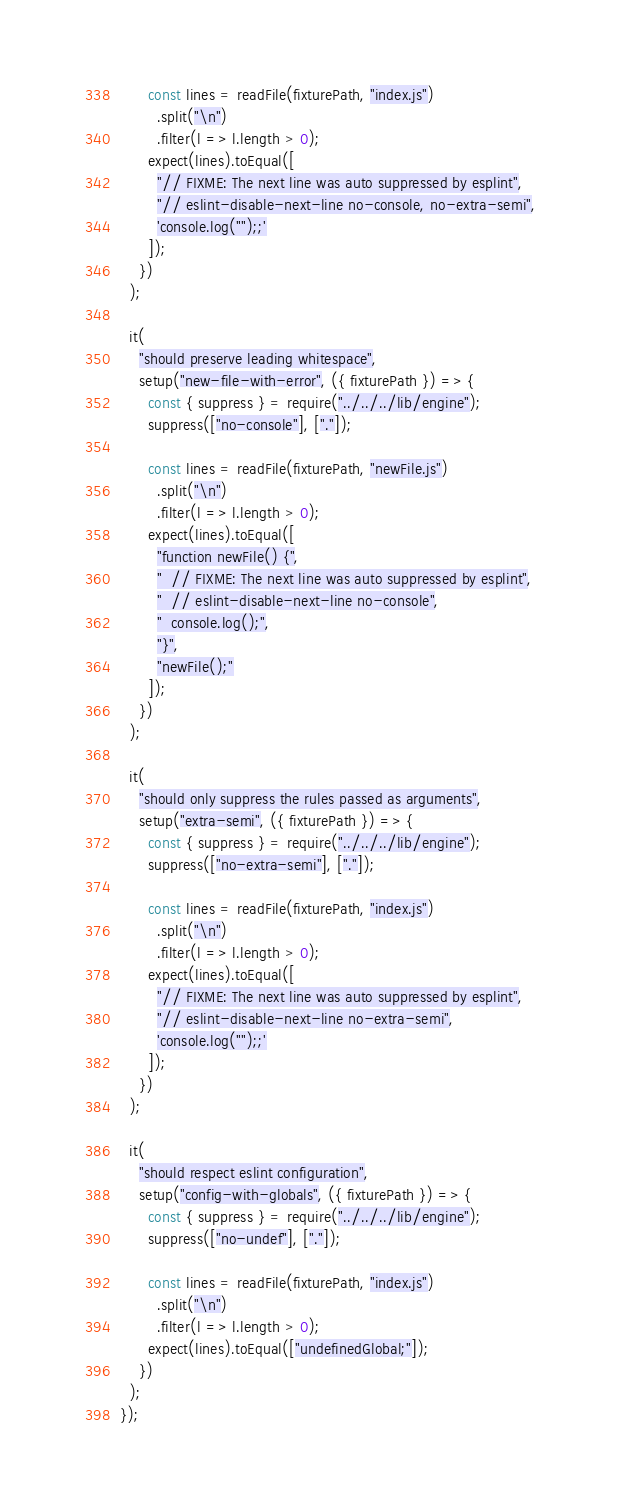Convert code to text. <code><loc_0><loc_0><loc_500><loc_500><_JavaScript_>      const lines = readFile(fixturePath, "index.js")
        .split("\n")
        .filter(l => l.length > 0);
      expect(lines).toEqual([
        "// FIXME: The next line was auto suppressed by esplint",
        "// eslint-disable-next-line no-console, no-extra-semi",
        'console.log("");;'
      ]);
    })
  );

  it(
    "should preserve leading whitespace",
    setup("new-file-with-error", ({ fixturePath }) => {
      const { suppress } = require("../../../lib/engine");
      suppress(["no-console"], ["."]);

      const lines = readFile(fixturePath, "newFile.js")
        .split("\n")
        .filter(l => l.length > 0);
      expect(lines).toEqual([
        "function newFile() {",
        "  // FIXME: The next line was auto suppressed by esplint",
        "  // eslint-disable-next-line no-console",
        "  console.log();",
        "}",
        "newFile();"
      ]);
    })
  );

  it(
    "should only suppress the rules passed as arguments",
    setup("extra-semi", ({ fixturePath }) => {
      const { suppress } = require("../../../lib/engine");
      suppress(["no-extra-semi"], ["."]);

      const lines = readFile(fixturePath, "index.js")
        .split("\n")
        .filter(l => l.length > 0);
      expect(lines).toEqual([
        "// FIXME: The next line was auto suppressed by esplint",
        "// eslint-disable-next-line no-extra-semi",
        'console.log("");;'
      ]);
    })
  );

  it(
    "should respect eslint configuration",
    setup("config-with-globals", ({ fixturePath }) => {
      const { suppress } = require("../../../lib/engine");
      suppress(["no-undef"], ["."]);

      const lines = readFile(fixturePath, "index.js")
        .split("\n")
        .filter(l => l.length > 0);
      expect(lines).toEqual(["undefinedGlobal;"]);
    })
  );
});
</code> 